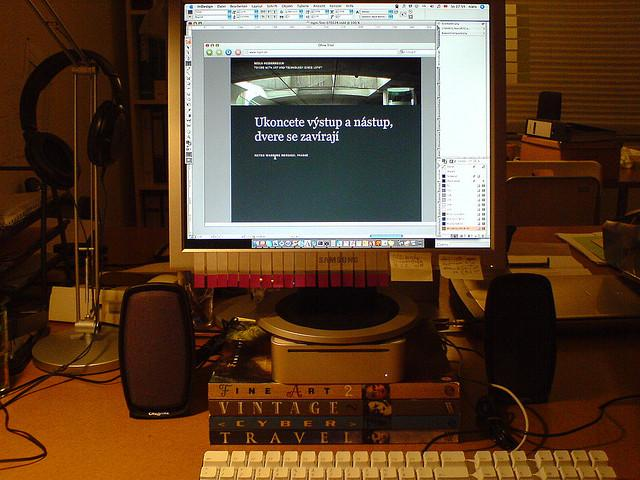What is the monitor sitting on top of above the desk? Please explain your reasoning. books. It looks like to be sitting on some books 